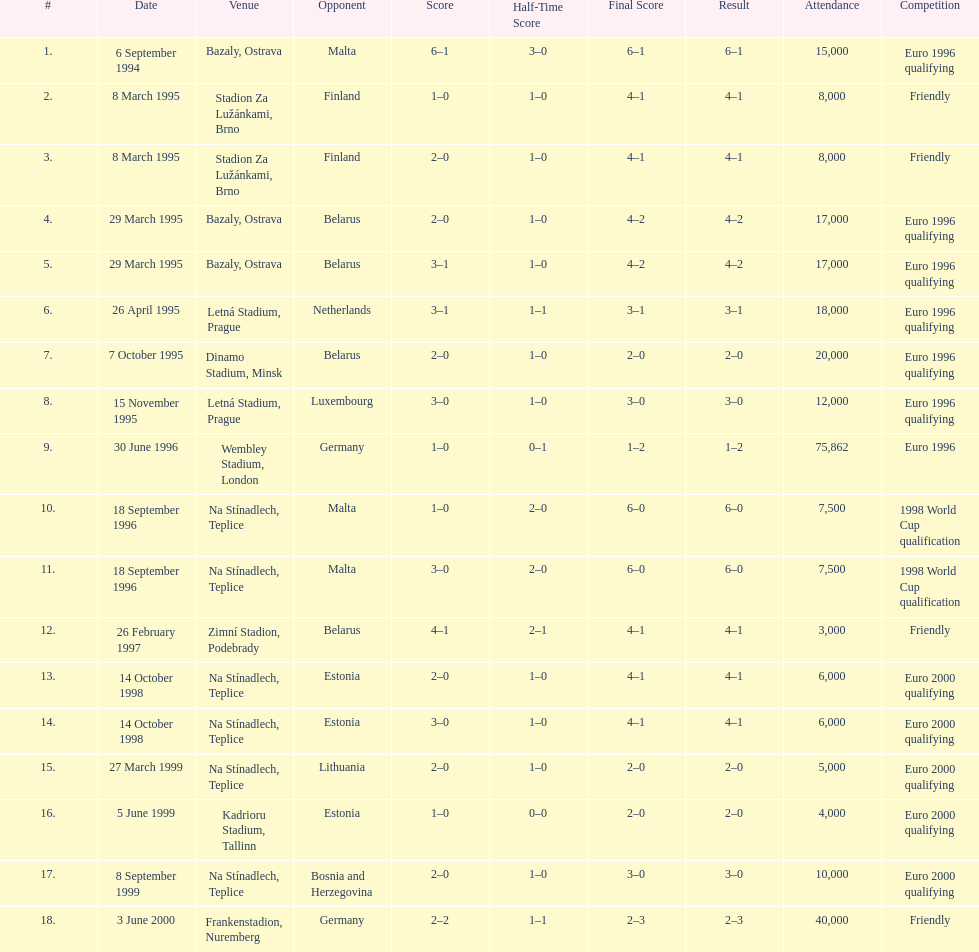What was the number of times czech republic played against germany? 2. 